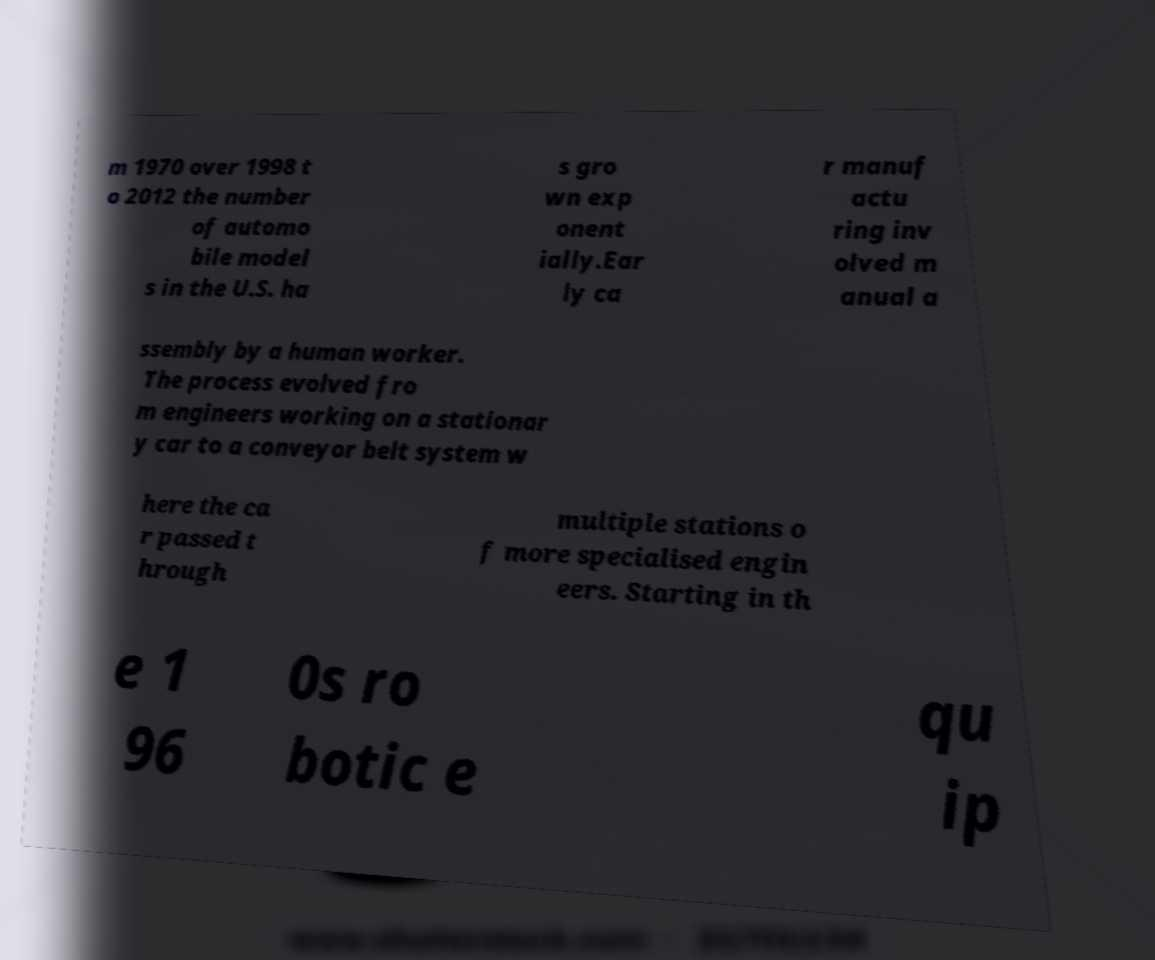Can you read and provide the text displayed in the image?This photo seems to have some interesting text. Can you extract and type it out for me? m 1970 over 1998 t o 2012 the number of automo bile model s in the U.S. ha s gro wn exp onent ially.Ear ly ca r manuf actu ring inv olved m anual a ssembly by a human worker. The process evolved fro m engineers working on a stationar y car to a conveyor belt system w here the ca r passed t hrough multiple stations o f more specialised engin eers. Starting in th e 1 96 0s ro botic e qu ip 